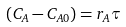Convert formula to latex. <formula><loc_0><loc_0><loc_500><loc_500>( C _ { A } - C _ { A 0 } ) = r _ { A } \tau</formula> 